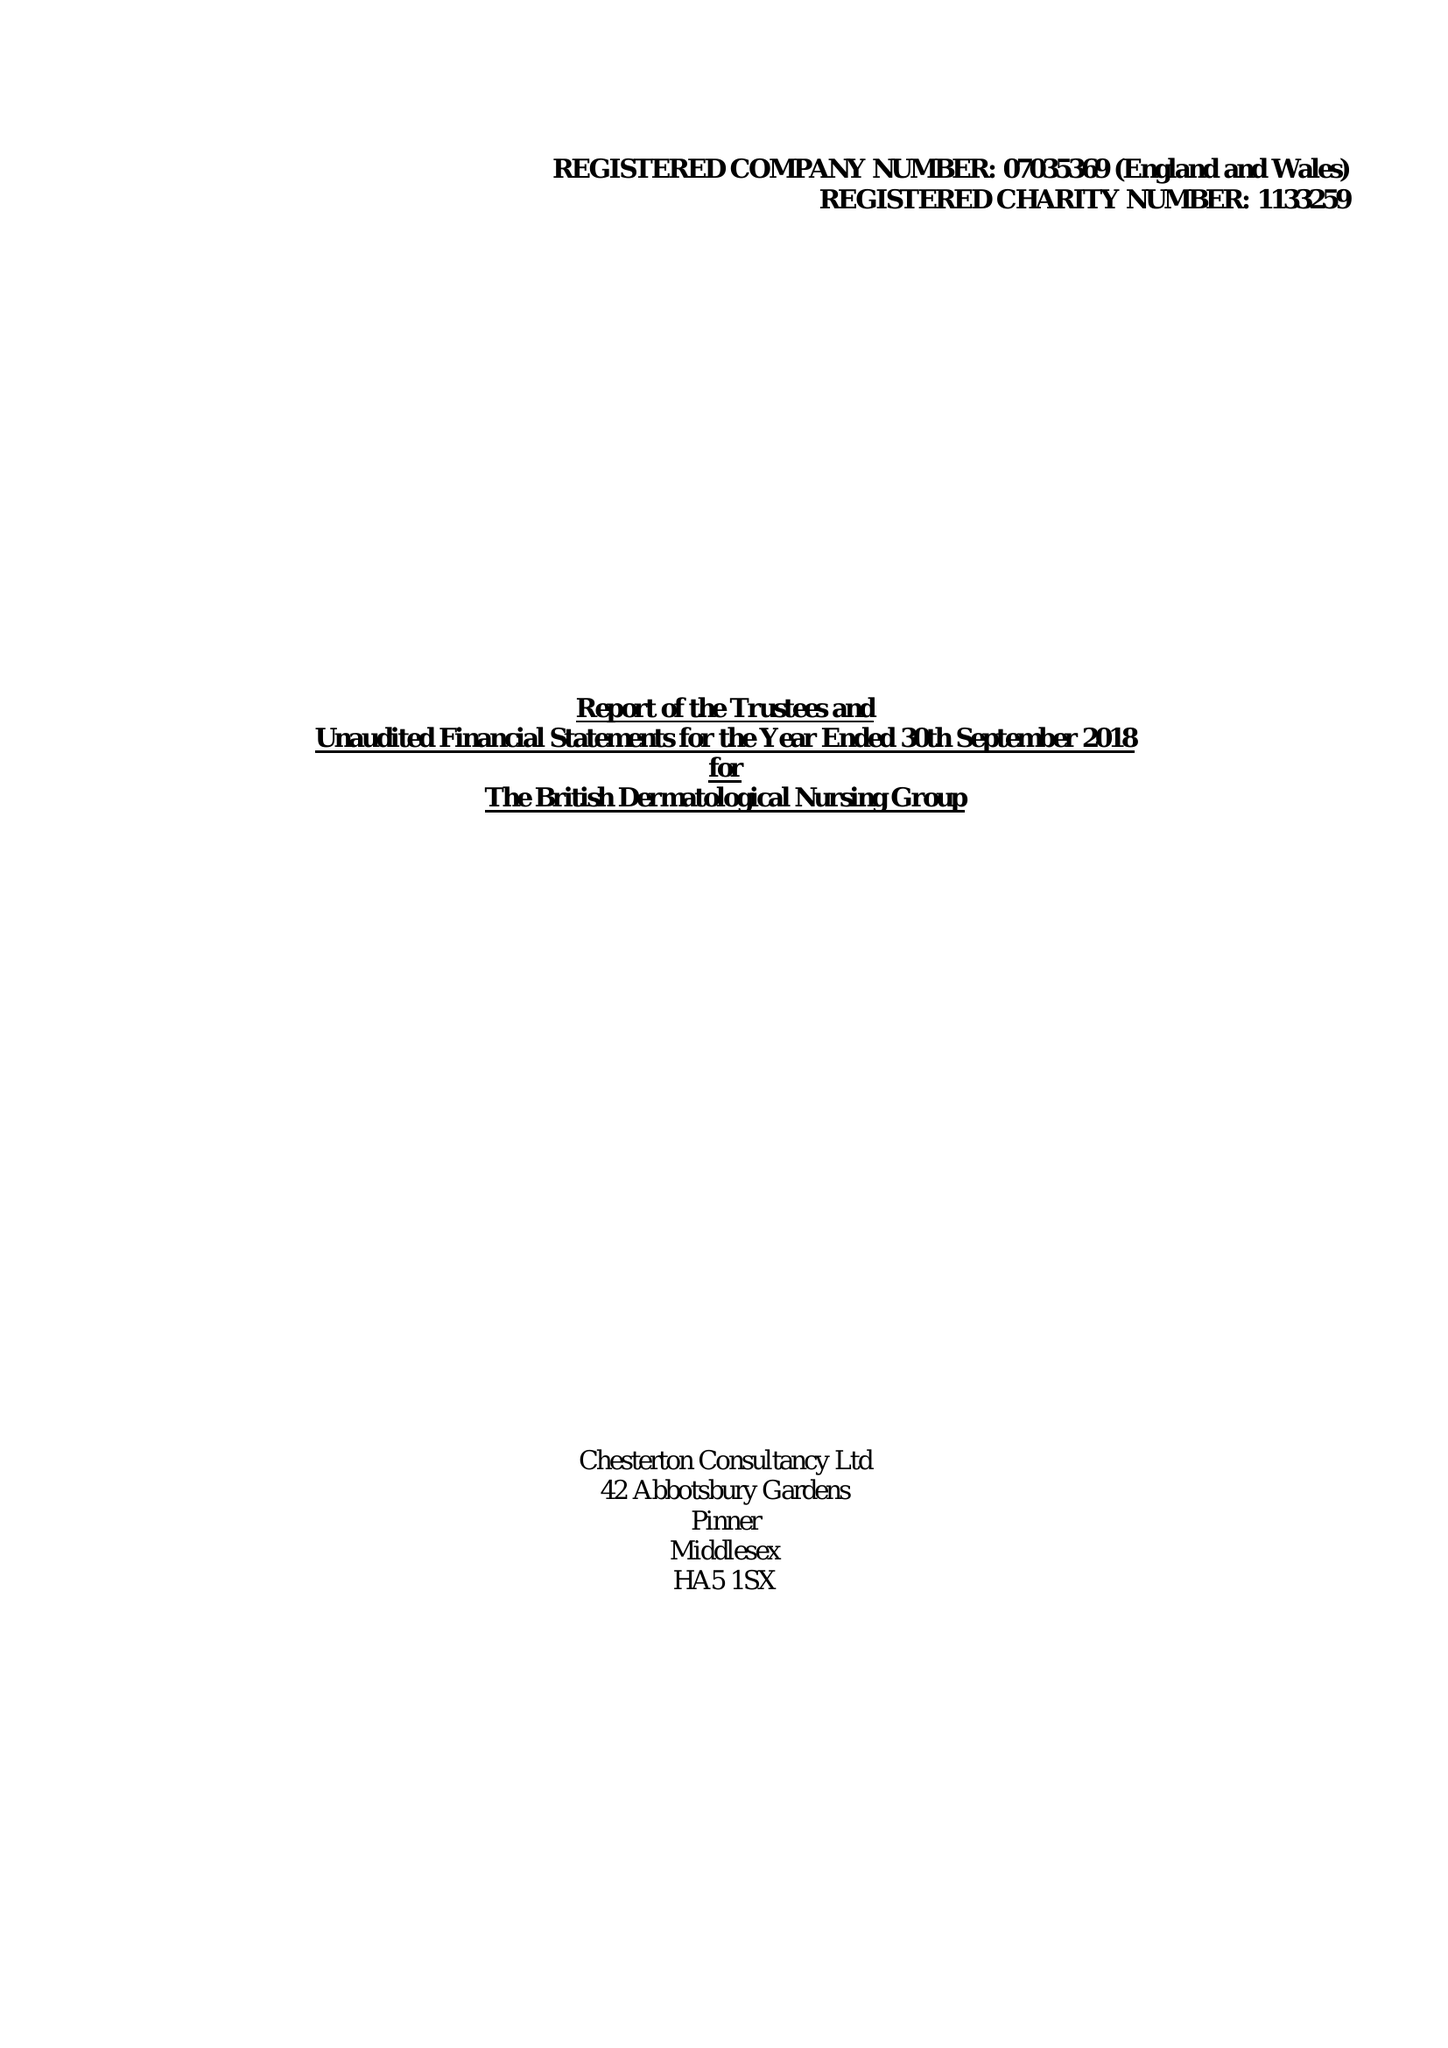What is the value for the spending_annually_in_british_pounds?
Answer the question using a single word or phrase. 360205.00 